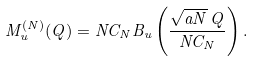Convert formula to latex. <formula><loc_0><loc_0><loc_500><loc_500>M _ { u } ^ { ( N ) } ( Q ) = N C _ { N } B _ { u } \left ( \frac { \sqrt { a N } \, Q } { N C _ { N } } \right ) .</formula> 